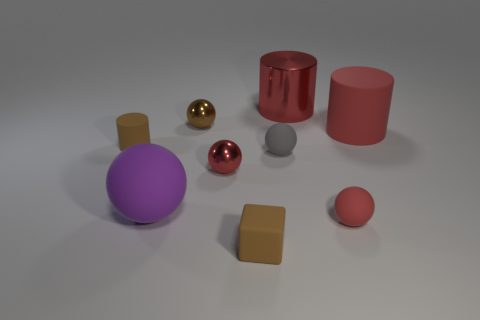Are there any cubes of the same color as the big metal object?
Keep it short and to the point. No. Does the red rubber thing to the left of the red rubber cylinder have the same size as the brown cube?
Provide a short and direct response. Yes. Is the number of tiny red matte things that are behind the brown shiny sphere the same as the number of blue matte cubes?
Ensure brevity in your answer.  Yes. What number of objects are either small shiny objects behind the tiny gray rubber ball or small brown spheres?
Ensure brevity in your answer.  1. The big thing that is both right of the brown block and to the left of the small red matte object has what shape?
Offer a very short reply. Cylinder. What number of objects are either tiny red things that are in front of the purple matte thing or brown objects that are behind the tiny gray rubber thing?
Your response must be concise. 3. What number of other objects are there of the same size as the brown ball?
Offer a terse response. 5. Is the color of the tiny thing left of the brown shiny thing the same as the tiny matte cube?
Your answer should be very brief. Yes. How big is the red thing that is both in front of the gray matte thing and behind the large purple matte sphere?
Keep it short and to the point. Small. How many small objects are either brown blocks or red rubber objects?
Give a very brief answer. 2. 